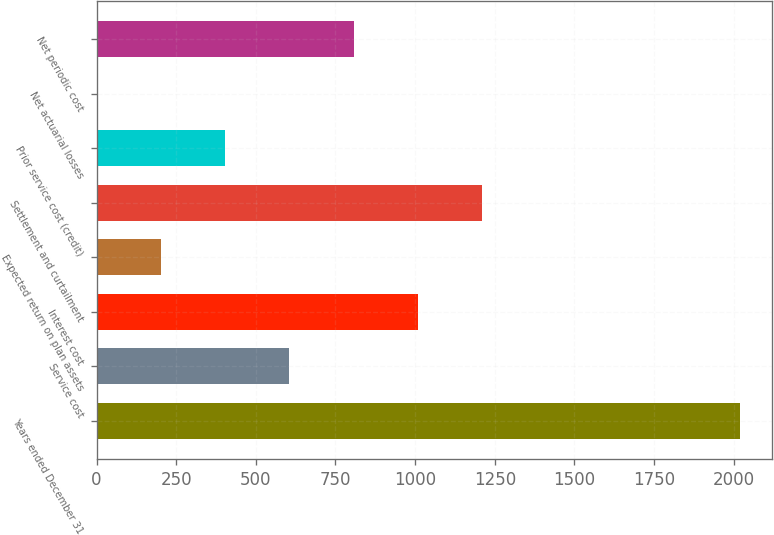Convert chart to OTSL. <chart><loc_0><loc_0><loc_500><loc_500><bar_chart><fcel>Years ended December 31<fcel>Service cost<fcel>Interest cost<fcel>Expected return on plan assets<fcel>Settlement and curtailment<fcel>Prior service cost (credit)<fcel>Net actuarial losses<fcel>Net periodic cost<nl><fcel>2018<fcel>605.47<fcel>1009.05<fcel>201.89<fcel>1210.84<fcel>403.68<fcel>0.1<fcel>807.26<nl></chart> 